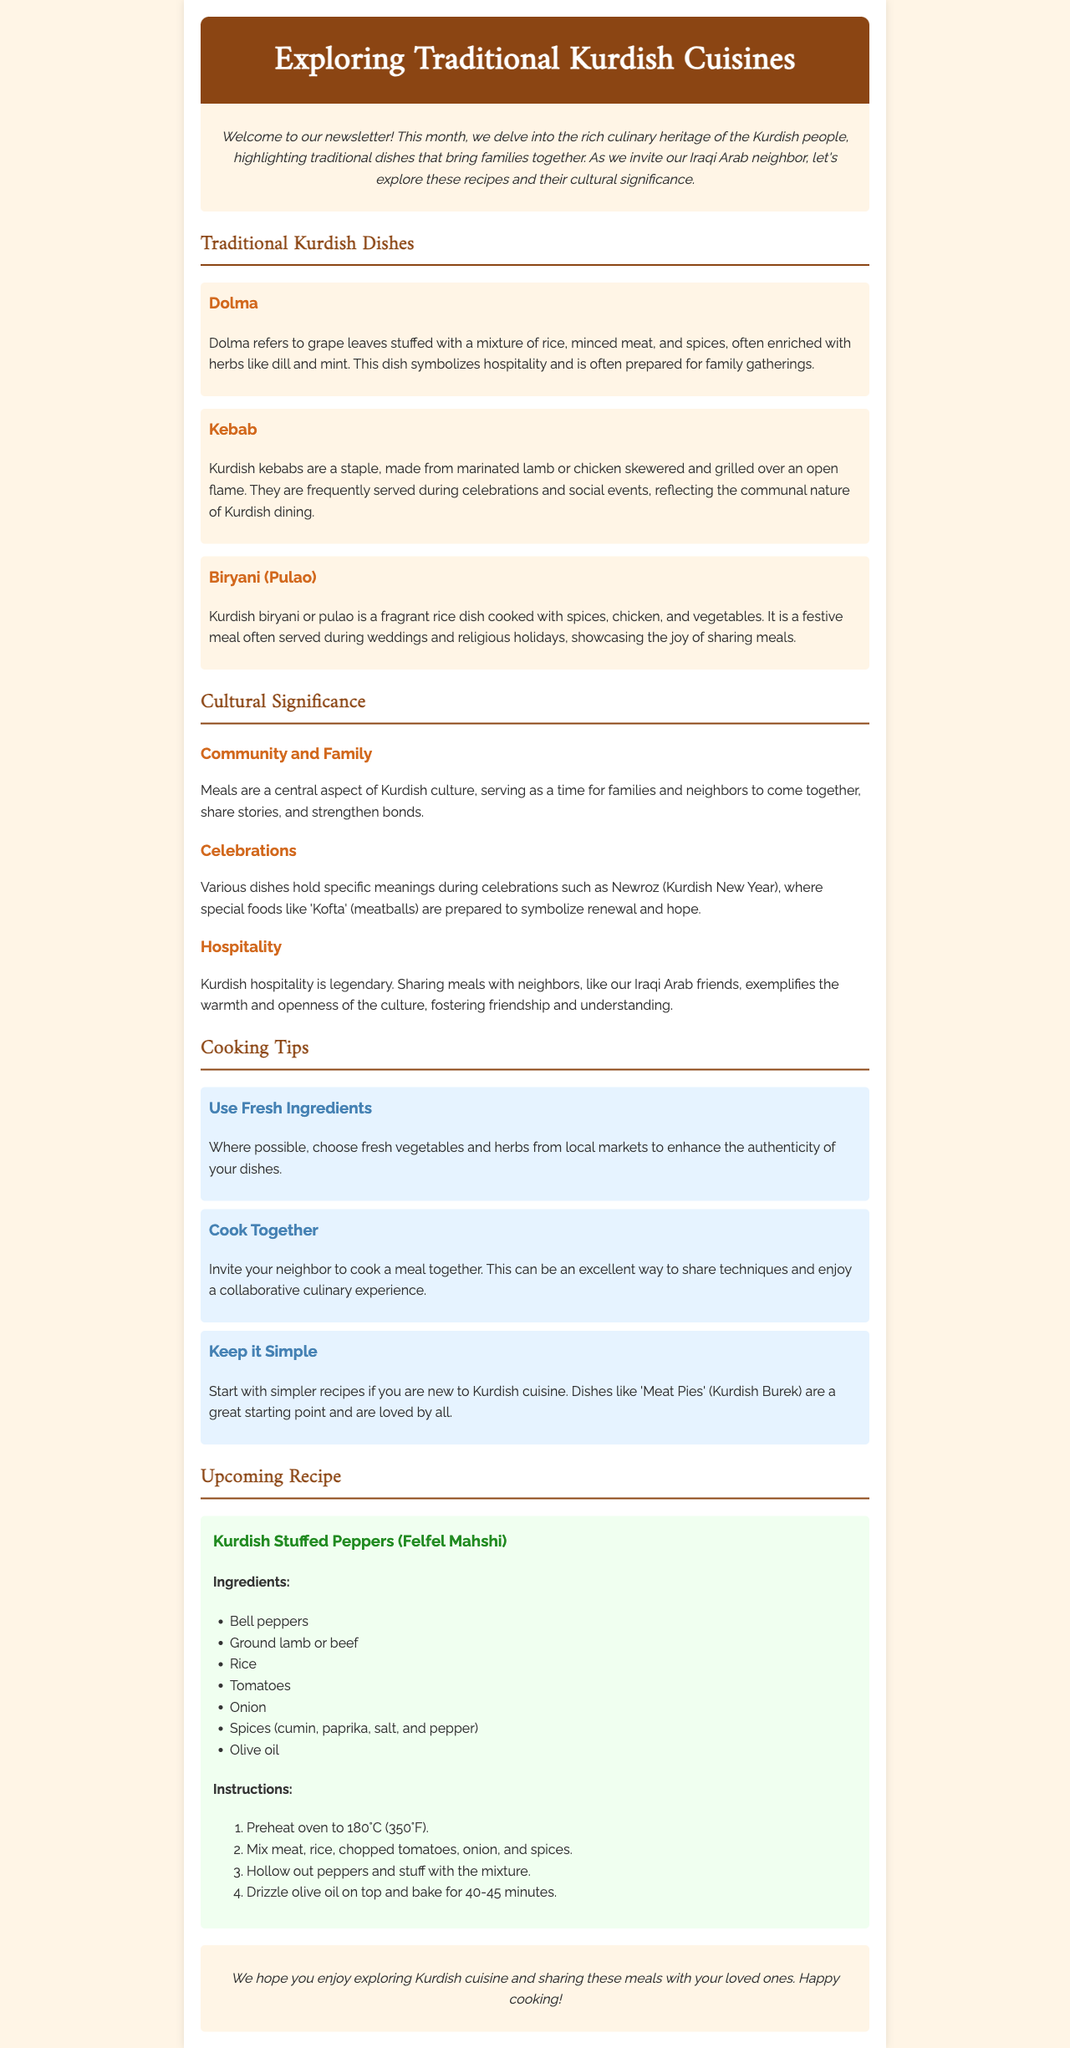What dish is symbolized by hospitality? The document states that Dolma symbolizes hospitality and is often prepared for family gatherings.
Answer: Dolma What main ingredient is used in Kurdish kebabs? The document mentions that Kurdish kebabs are made from marinated lamb or chicken.
Answer: Lamb or chicken During which festival is 'Kofta' typically prepared? The document indicates that 'Kofta' is prepared during the Newroz festival to symbolize renewal and hope.
Answer: Newroz What type of cuisine does the newsletter focus on? The newsletter is specifically about traditional Kurdish cuisines, highlighting dishes and their significance.
Answer: Kurdish What is suggested to enhance the authenticity of dishes? The cooking tip suggests using fresh vegetables and herbs from local markets.
Answer: Fresh ingredients How long should Kurdish stuffed peppers be baked? The document provides the baking time for Kurdish stuffed peppers as 40-45 minutes.
Answer: 40-45 minutes What is recommended for those new to Kurdish cuisine? The document advises starting with simpler recipes like 'Meat Pies' (Kurdish Burek).
Answer: Meat Pies What color is the header background of the newsletter? The document states that the header background color is #8B4513, which is a shade of brown.
Answer: Brown 